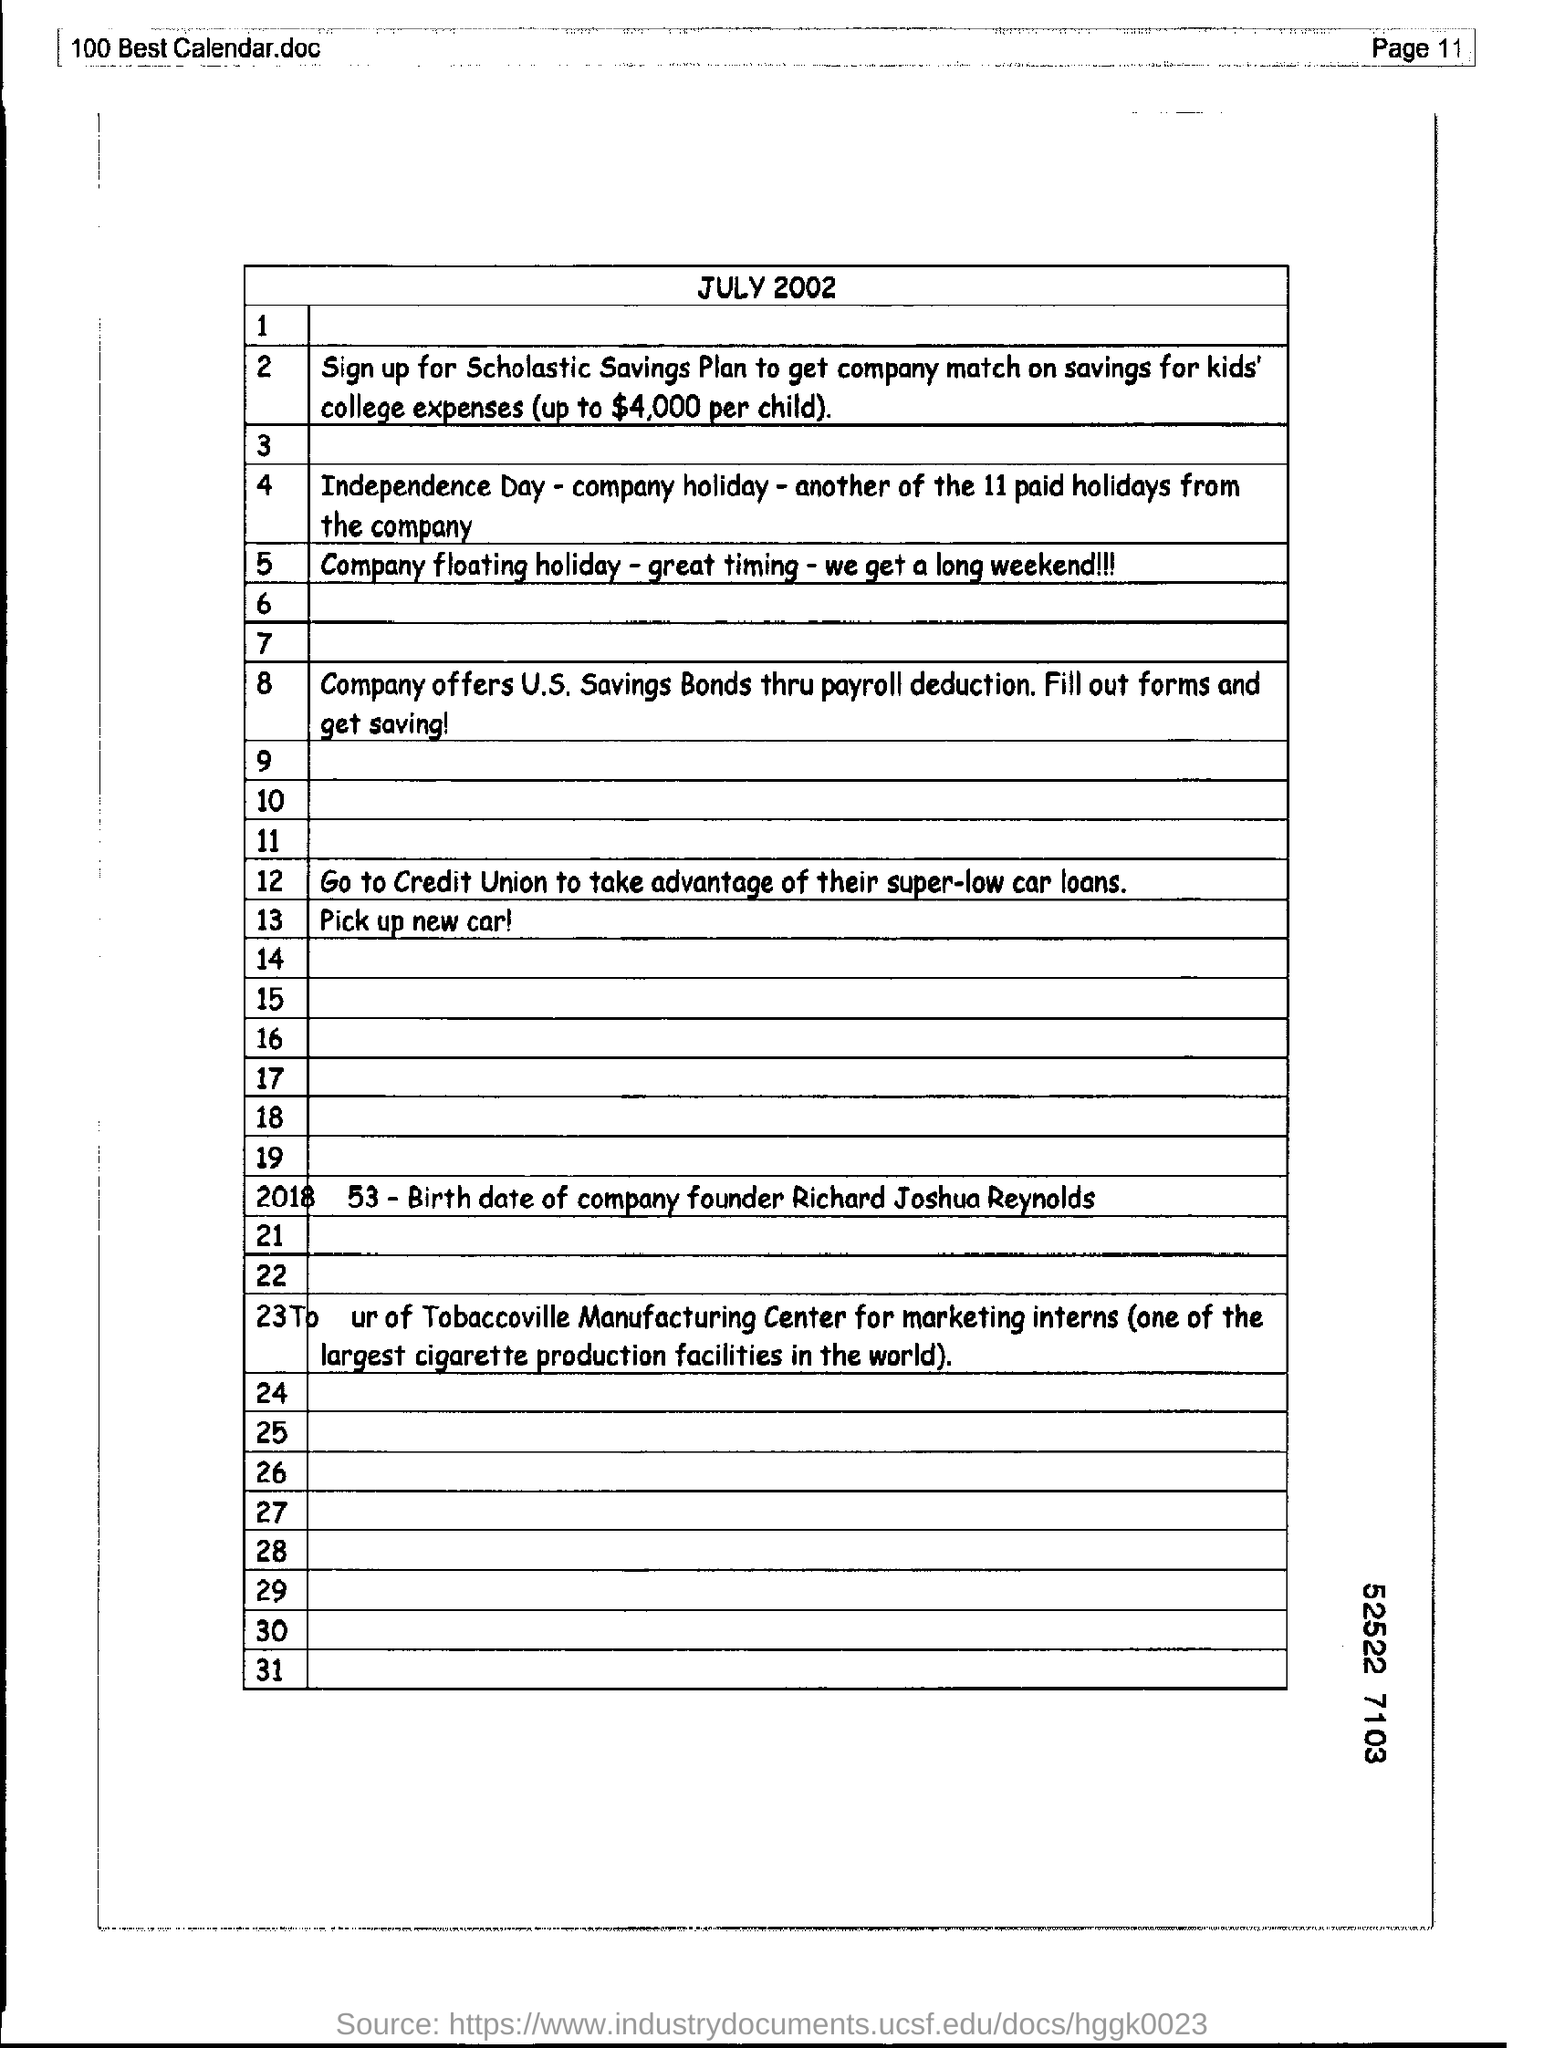Draw attention to some important aspects in this diagram. The document mentions July 2002. Please mention the page number at the top right corner of the page, specifically 11.. 